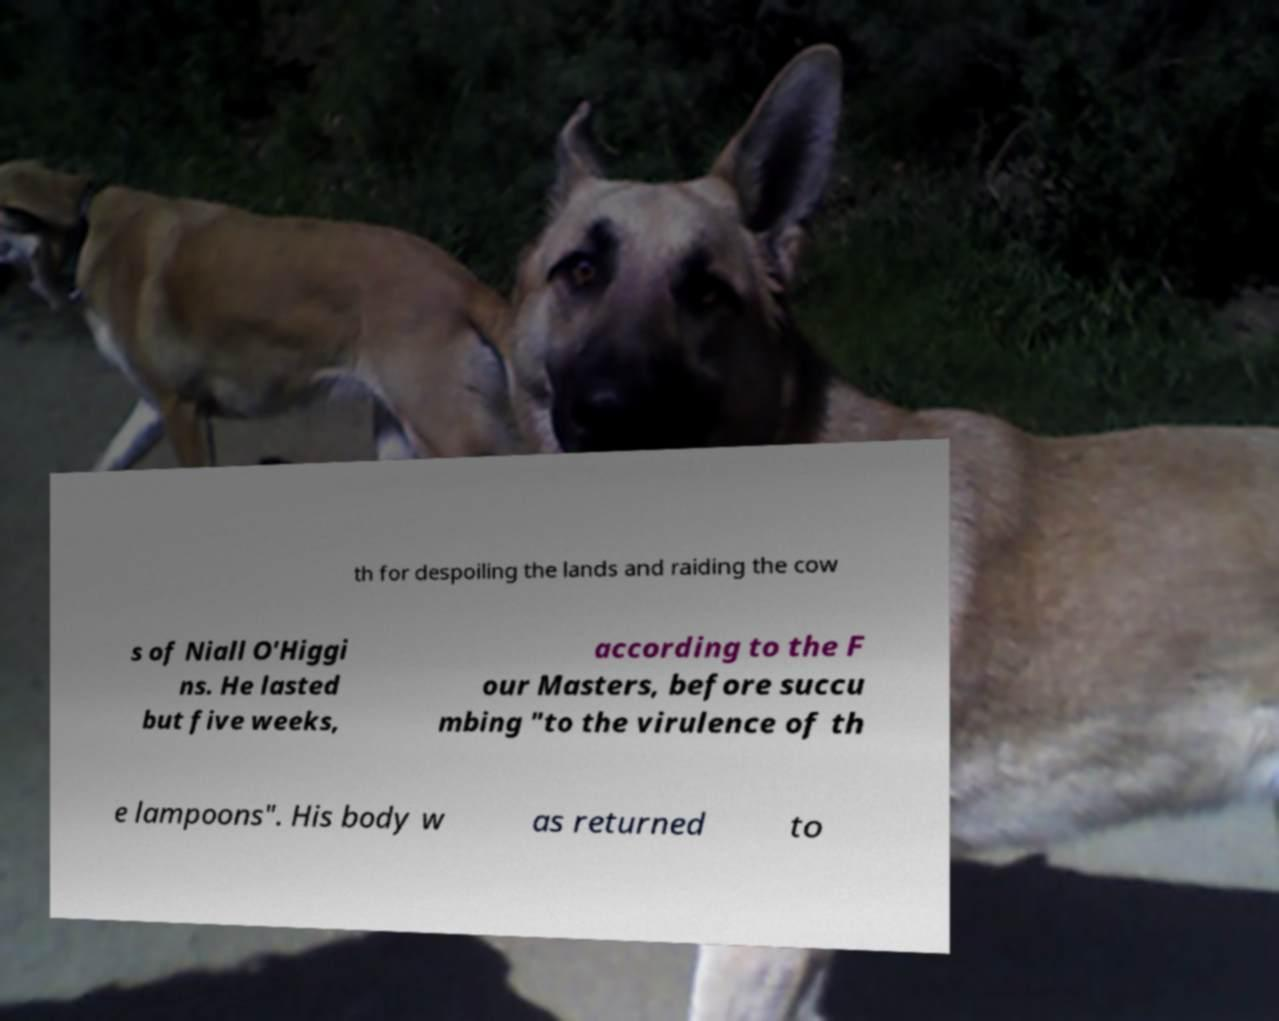For documentation purposes, I need the text within this image transcribed. Could you provide that? th for despoiling the lands and raiding the cow s of Niall O'Higgi ns. He lasted but five weeks, according to the F our Masters, before succu mbing "to the virulence of th e lampoons". His body w as returned to 